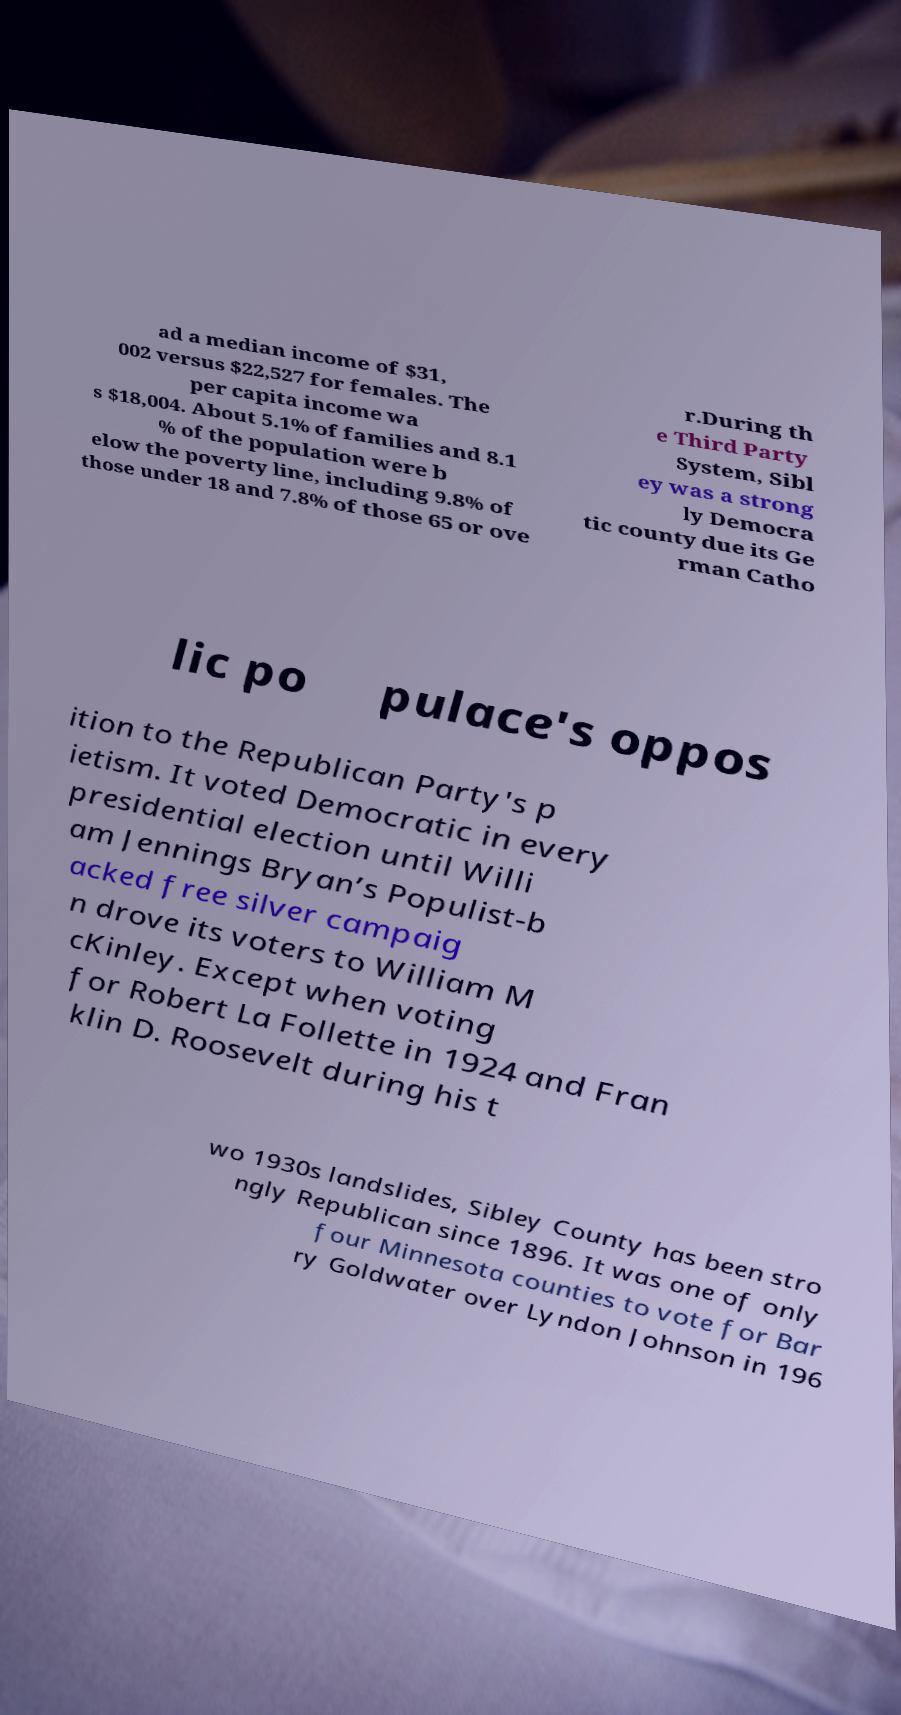Could you extract and type out the text from this image? ad a median income of $31, 002 versus $22,527 for females. The per capita income wa s $18,004. About 5.1% of families and 8.1 % of the population were b elow the poverty line, including 9.8% of those under 18 and 7.8% of those 65 or ove r.During th e Third Party System, Sibl ey was a strong ly Democra tic county due its Ge rman Catho lic po pulace's oppos ition to the Republican Party's p ietism. It voted Democratic in every presidential election until Willi am Jennings Bryan’s Populist-b acked free silver campaig n drove its voters to William M cKinley. Except when voting for Robert La Follette in 1924 and Fran klin D. Roosevelt during his t wo 1930s landslides, Sibley County has been stro ngly Republican since 1896. It was one of only four Minnesota counties to vote for Bar ry Goldwater over Lyndon Johnson in 196 